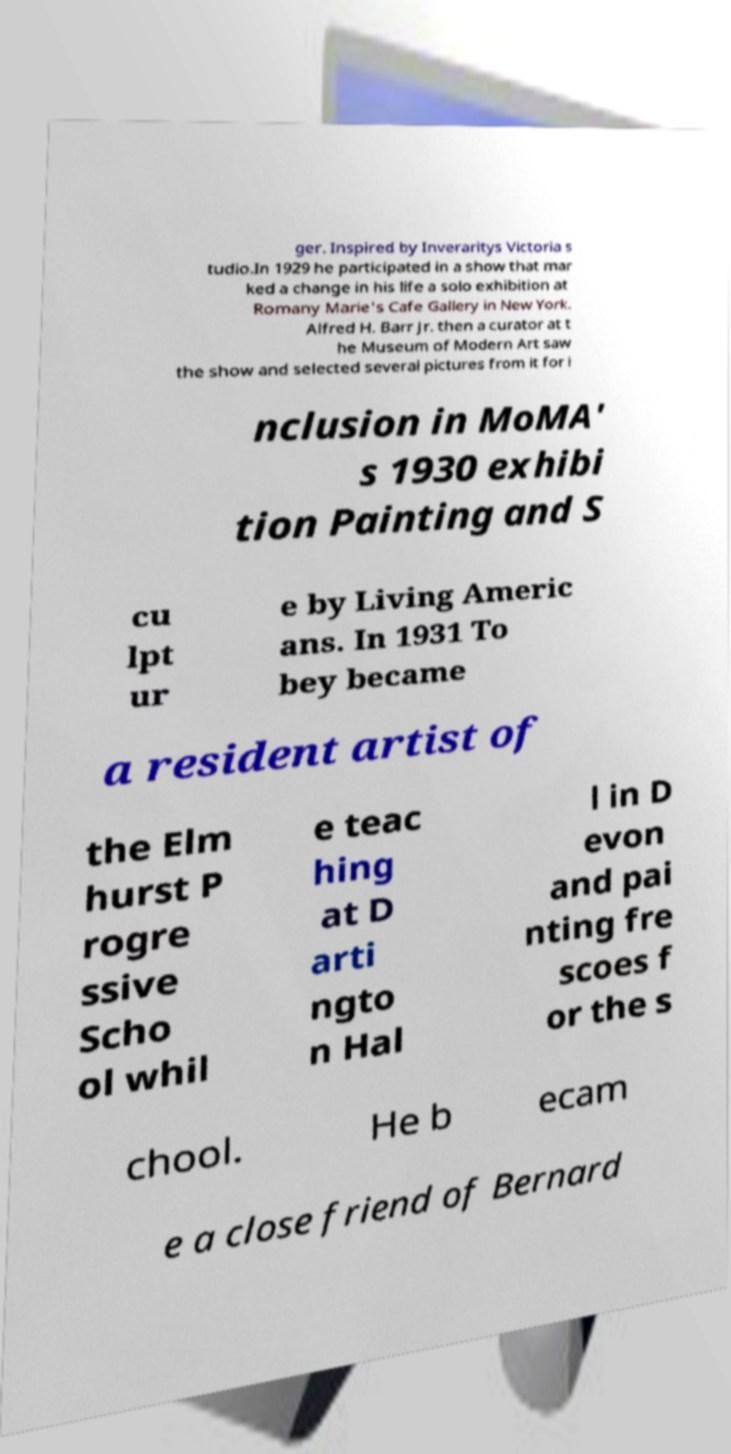Please identify and transcribe the text found in this image. ger. Inspired by Inveraritys Victoria s tudio.In 1929 he participated in a show that mar ked a change in his life a solo exhibition at Romany Marie's Cafe Gallery in New York. Alfred H. Barr Jr. then a curator at t he Museum of Modern Art saw the show and selected several pictures from it for i nclusion in MoMA' s 1930 exhibi tion Painting and S cu lpt ur e by Living Americ ans. In 1931 To bey became a resident artist of the Elm hurst P rogre ssive Scho ol whil e teac hing at D arti ngto n Hal l in D evon and pai nting fre scoes f or the s chool. He b ecam e a close friend of Bernard 